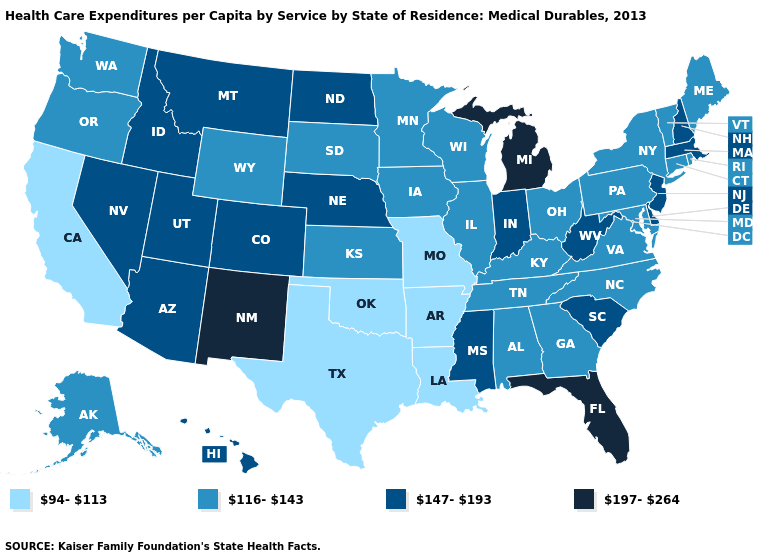Name the states that have a value in the range 94-113?
Keep it brief. Arkansas, California, Louisiana, Missouri, Oklahoma, Texas. Is the legend a continuous bar?
Short answer required. No. What is the highest value in the USA?
Concise answer only. 197-264. What is the value of Louisiana?
Give a very brief answer. 94-113. What is the highest value in states that border Michigan?
Keep it brief. 147-193. Which states have the lowest value in the USA?
Answer briefly. Arkansas, California, Louisiana, Missouri, Oklahoma, Texas. What is the value of Washington?
Concise answer only. 116-143. What is the value of Idaho?
Write a very short answer. 147-193. What is the value of Colorado?
Keep it brief. 147-193. What is the lowest value in states that border Minnesota?
Quick response, please. 116-143. What is the value of Rhode Island?
Write a very short answer. 116-143. Which states have the highest value in the USA?
Give a very brief answer. Florida, Michigan, New Mexico. What is the value of Connecticut?
Give a very brief answer. 116-143. What is the value of Illinois?
Give a very brief answer. 116-143. Which states have the lowest value in the USA?
Concise answer only. Arkansas, California, Louisiana, Missouri, Oklahoma, Texas. 